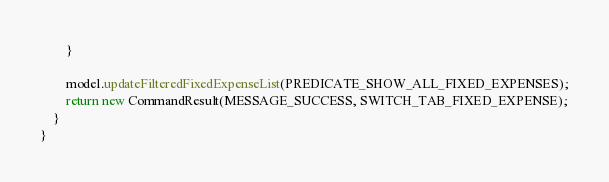Convert code to text. <code><loc_0><loc_0><loc_500><loc_500><_Java_>        }

        model.updateFilteredFixedExpenseList(PREDICATE_SHOW_ALL_FIXED_EXPENSES);
        return new CommandResult(MESSAGE_SUCCESS, SWITCH_TAB_FIXED_EXPENSE);
    }
}
</code> 